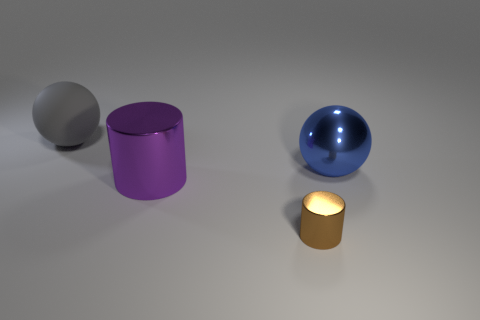Subtract all blue cylinders. Subtract all cyan cubes. How many cylinders are left? 2 Add 1 blue spheres. How many objects exist? 5 Subtract 0 gray cylinders. How many objects are left? 4 Subtract all purple things. Subtract all blue cylinders. How many objects are left? 3 Add 2 metallic objects. How many metallic objects are left? 5 Add 4 tiny green metal things. How many tiny green metal things exist? 4 